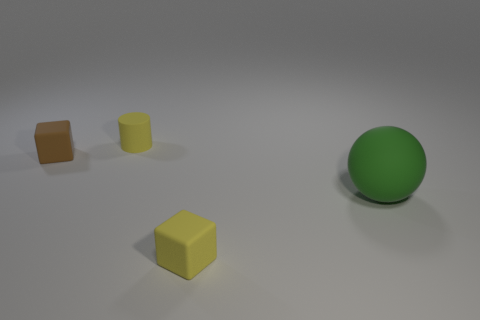What colors are the blocks in the image? The blocks in the image are brown and yellow. 
Which block is closest to the green sphere? The yellow block is closest to the green sphere. 